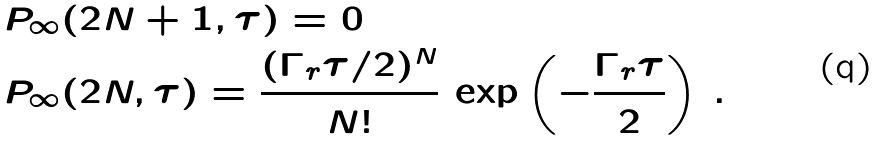<formula> <loc_0><loc_0><loc_500><loc_500>& P _ { \infty } ( 2 N + 1 , \tau ) = 0 \\ & P _ { \infty } ( 2 N , \tau ) = \frac { ( \Gamma _ { r } \tau / 2 ) ^ { N } } { N ! } \, \exp \left ( - \frac { \Gamma _ { r } \tau } { 2 } \right ) \, .</formula> 